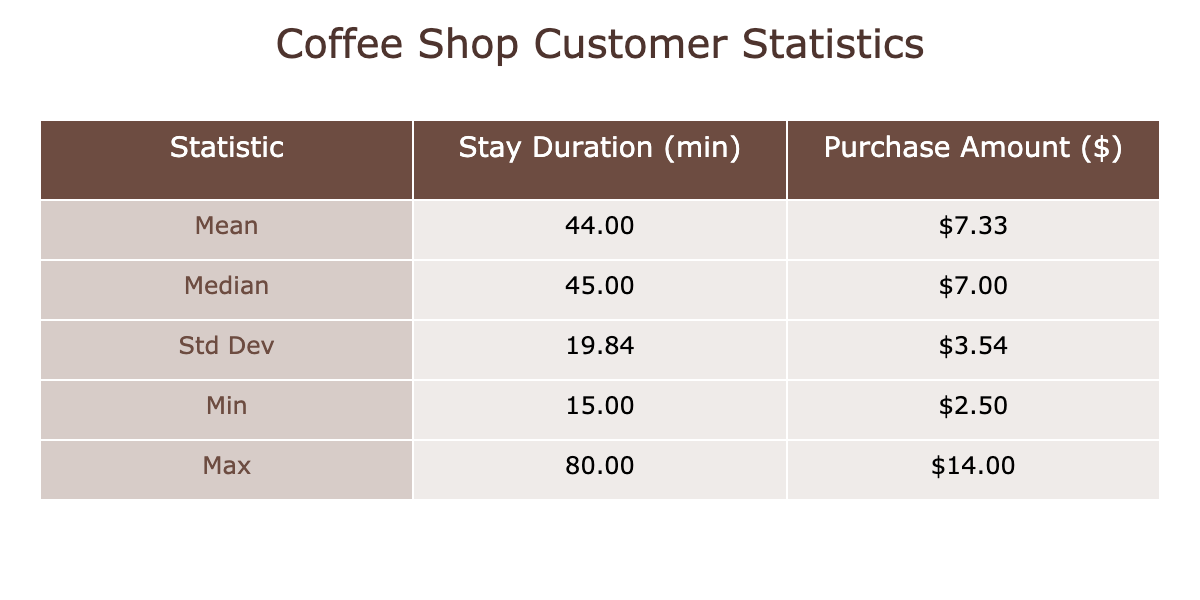What is the mean stay duration for customers? The table provides the mean stay duration value directly under the 'Stay Duration (min)' column. This value is listed as 45.00 minutes.
Answer: 45.00 What is the maximum purchase amount recorded? The maximum purchase amount can be found under the 'Purchase Amount ($)' column, which shows a maximum value of $14.00.
Answer: $14.00 Is the median stay duration greater than the median purchase amount? The median stay duration is listed as 50.00 minutes, while the median purchase amount is $7.00. Since 50.00 is greater than 7.00, the answer is yes.
Answer: Yes What is the standard deviation of the stay duration? The standard deviation for the stay duration can be found in the corresponding row in the table, where it is stated to be 18.13 minutes.
Answer: 18.13 If a customer stayed for 80 minutes, what was their purchase amount? In the data, the entry with a stay duration of 80 minutes corresponds to a purchase amount of $14.00, which can be directly referred to from the table.
Answer: $14.00 What is the difference between the maximum and minimum purchase amounts? The maximum purchase amount is $14.00, and the minimum is $2.50. The difference is calculated as $14.00 - $2.50 = $11.50.
Answer: $11.50 How many customers had a stay duration less than the mean duration? The mean stay duration is 45.00 minutes. Looking at the data, customers with IDs 1, 4, 7, 9, and 11 stayed less than 45.00 minutes, which totals to 5 customers.
Answer: 5 What is the average purchase amount of customers who stayed more than 50 minutes? Customers with stay durations above 50 minutes are IDs 6 (8.75), 10 (12.50), 12 (11.00), and 13 (14.00). To find the average: (8.75 + 12.50 + 11.00 + 14.00) / 4 = $11.06.
Answer: $11.06 Are there any customers who spent less than $3.00? The minimum purchase amount recorded is $2.50, which indicates there is at least one customer who spent less than $3.00. Thus, the answer is yes.
Answer: Yes What is the range of the stay durations? The range is calculated as the maximum stay duration (80 minutes) minus the minimum stay duration (15 minutes), resulting in a range of 80 - 15 = 65 minutes.
Answer: 65 minutes 